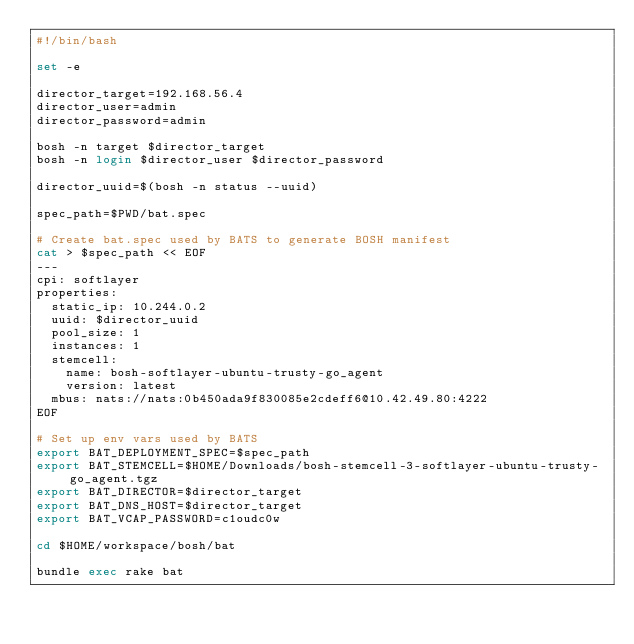Convert code to text. <code><loc_0><loc_0><loc_500><loc_500><_Bash_>#!/bin/bash

set -e

director_target=192.168.56.4
director_user=admin
director_password=admin

bosh -n target $director_target
bosh -n login $director_user $director_password

director_uuid=$(bosh -n status --uuid)

spec_path=$PWD/bat.spec

# Create bat.spec used by BATS to generate BOSH manifest
cat > $spec_path << EOF
---
cpi: softlayer
properties:
  static_ip: 10.244.0.2
  uuid: $director_uuid
  pool_size: 1
  instances: 1
  stemcell:
    name: bosh-softlayer-ubuntu-trusty-go_agent
    version: latest
  mbus: nats://nats:0b450ada9f830085e2cdeff6@10.42.49.80:4222
EOF

# Set up env vars used by BATS
export BAT_DEPLOYMENT_SPEC=$spec_path
export BAT_STEMCELL=$HOME/Downloads/bosh-stemcell-3-softlayer-ubuntu-trusty-go_agent.tgz
export BAT_DIRECTOR=$director_target
export BAT_DNS_HOST=$director_target
export BAT_VCAP_PASSWORD=c1oudc0w

cd $HOME/workspace/bosh/bat

bundle exec rake bat
</code> 